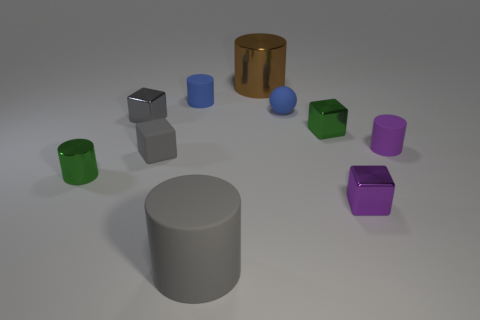Is there anything else that is the same shape as the gray shiny thing? Yes, there is a cylinder similar to the gray shiny one, which appears to be the brown metallic cylinder on the right side of the image. 